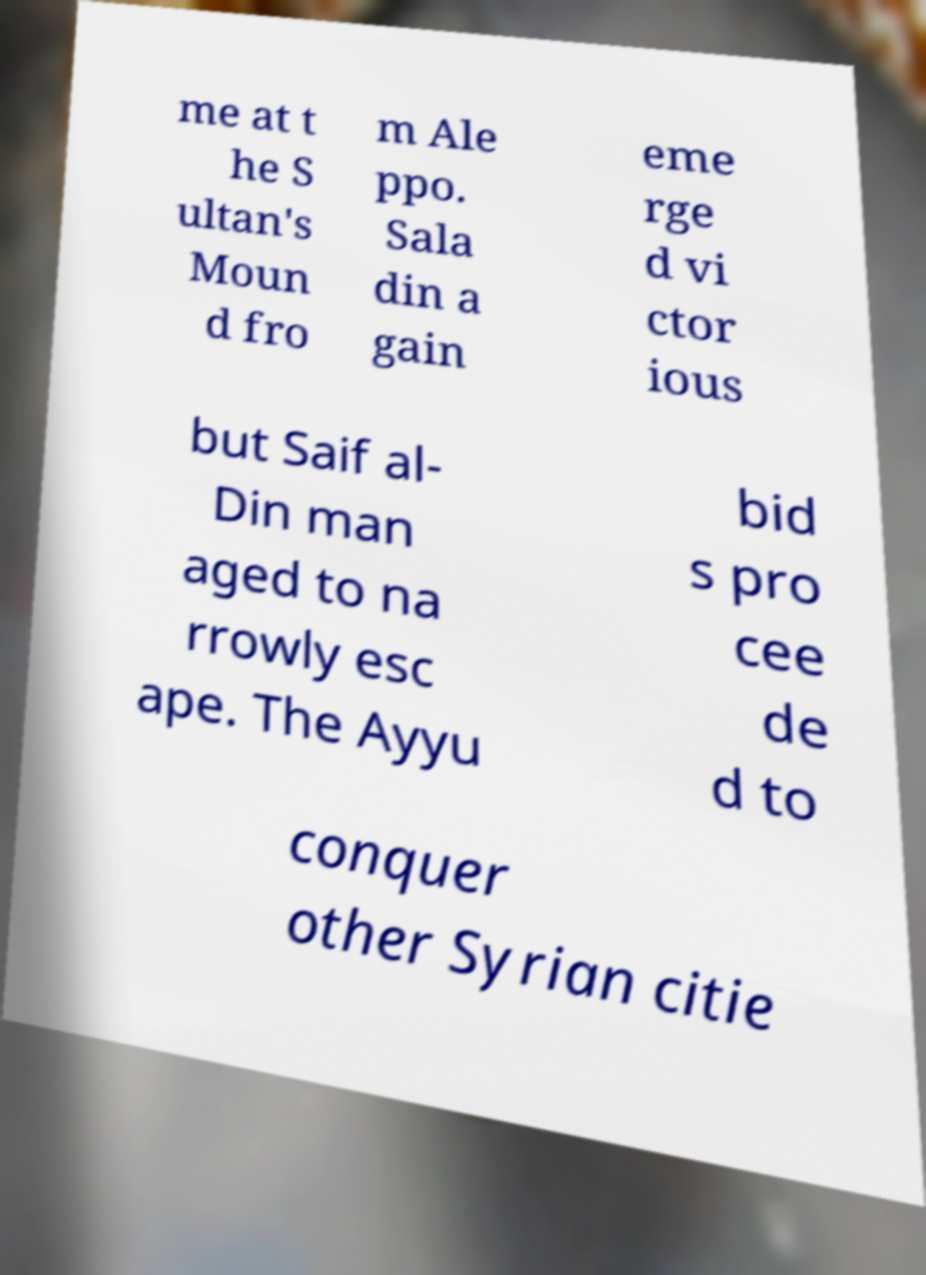Can you accurately transcribe the text from the provided image for me? me at t he S ultan's Moun d fro m Ale ppo. Sala din a gain eme rge d vi ctor ious but Saif al- Din man aged to na rrowly esc ape. The Ayyu bid s pro cee de d to conquer other Syrian citie 